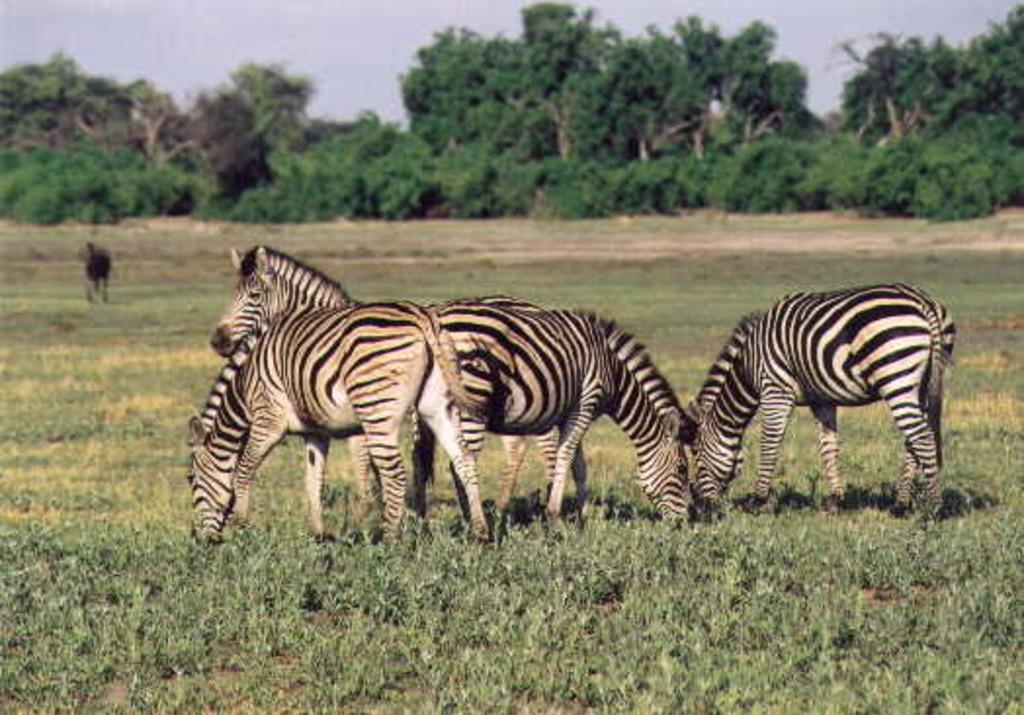What animals are present in the image? There is a group of zebras in the image. What is the zebras' location in the image? The zebras are on the grass. What else can be seen in the background of the image? There is an animal on the ground and trees in the background of the image. What is visible above the background elements? The sky is visible in the background of the image. What type of lumber is being used to build the fence in the image? There is no fence present in the image, so it is not possible to determine the type of lumber being used. 